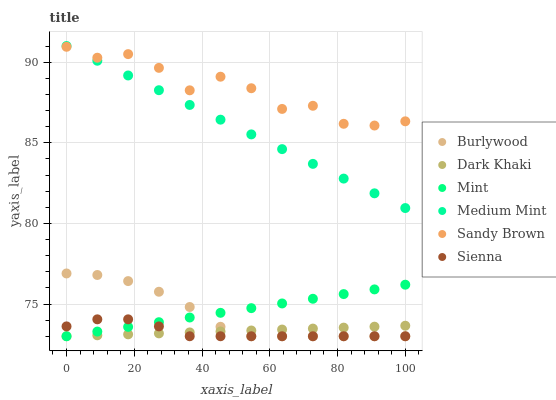Does Sienna have the minimum area under the curve?
Answer yes or no. Yes. Does Sandy Brown have the maximum area under the curve?
Answer yes or no. Yes. Does Burlywood have the minimum area under the curve?
Answer yes or no. No. Does Burlywood have the maximum area under the curve?
Answer yes or no. No. Is Mint the smoothest?
Answer yes or no. Yes. Is Sandy Brown the roughest?
Answer yes or no. Yes. Is Sienna the smoothest?
Answer yes or no. No. Is Sienna the roughest?
Answer yes or no. No. Does Sienna have the lowest value?
Answer yes or no. Yes. Does Sandy Brown have the lowest value?
Answer yes or no. No. Does Medium Mint have the highest value?
Answer yes or no. Yes. Does Sienna have the highest value?
Answer yes or no. No. Is Dark Khaki less than Sandy Brown?
Answer yes or no. Yes. Is Medium Mint greater than Sienna?
Answer yes or no. Yes. Does Sienna intersect Burlywood?
Answer yes or no. Yes. Is Sienna less than Burlywood?
Answer yes or no. No. Is Sienna greater than Burlywood?
Answer yes or no. No. Does Dark Khaki intersect Sandy Brown?
Answer yes or no. No. 